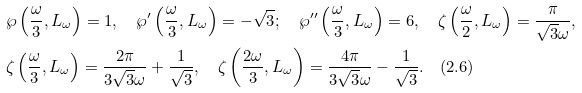<formula> <loc_0><loc_0><loc_500><loc_500>& \wp \left ( \frac { \omega } { 3 } , L _ { \omega } \right ) = 1 , \quad \wp ^ { \prime } \left ( \frac { \omega } { 3 } , L _ { \omega } \right ) = - \sqrt { 3 } ; \quad \wp ^ { \prime \prime } \left ( \frac { \omega } { 3 } , L _ { \omega } \right ) = 6 , \quad \zeta \left ( \frac { \omega } { 2 } , L _ { \omega } \right ) = \frac { \pi } { \sqrt { 3 } \omega } , \\ & \zeta \left ( \frac { \omega } { 3 } , L _ { \omega } \right ) = \frac { 2 \pi } { 3 \sqrt { 3 } \omega } + \frac { 1 } { \sqrt { 3 } } , \quad \zeta \left ( \frac { 2 \omega } { 3 } , L _ { \omega } \right ) = \frac { 4 \pi } { 3 \sqrt { 3 } \omega } - \frac { 1 } { \sqrt { 3 } } . \quad ( 2 . 6 )</formula> 